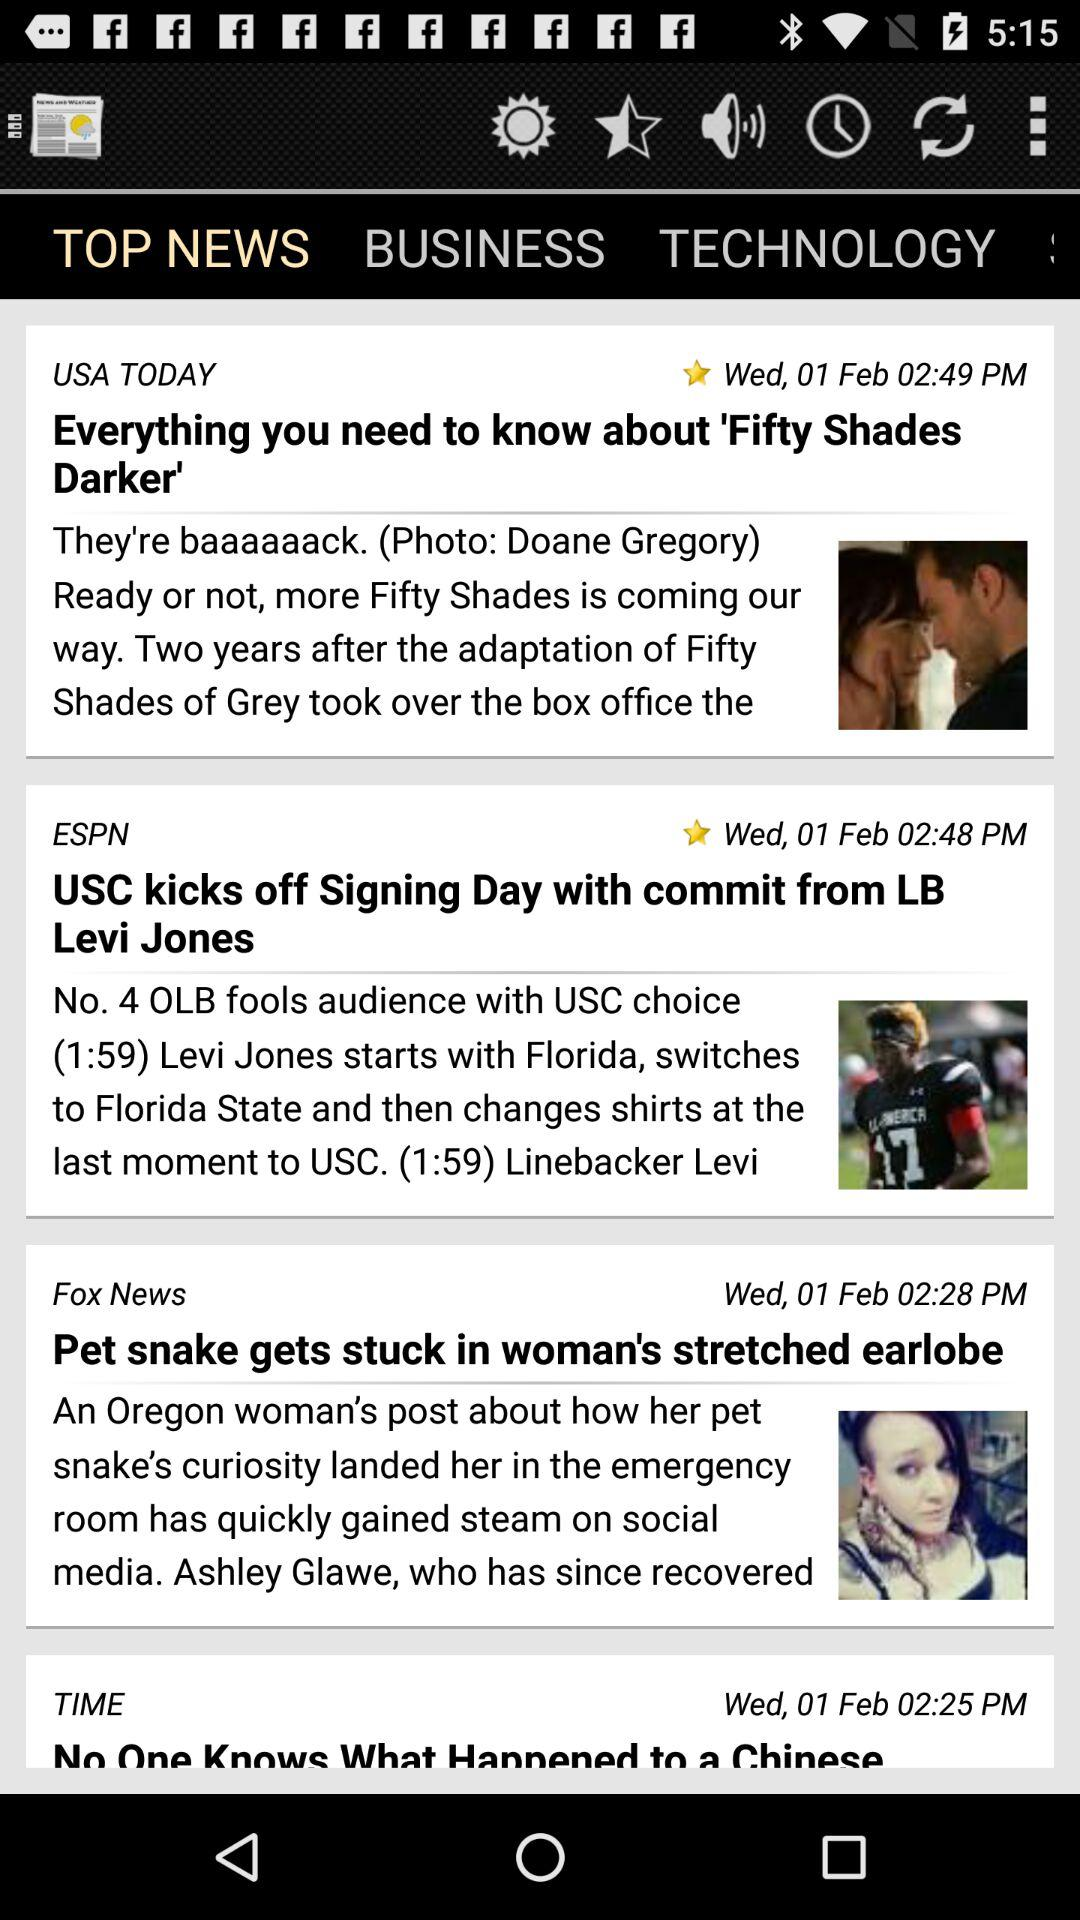On what date was the news "USC kicks off Signing Day with commit from LB Levi Jones" posted? The news was posted on Wednesday, February 1. 